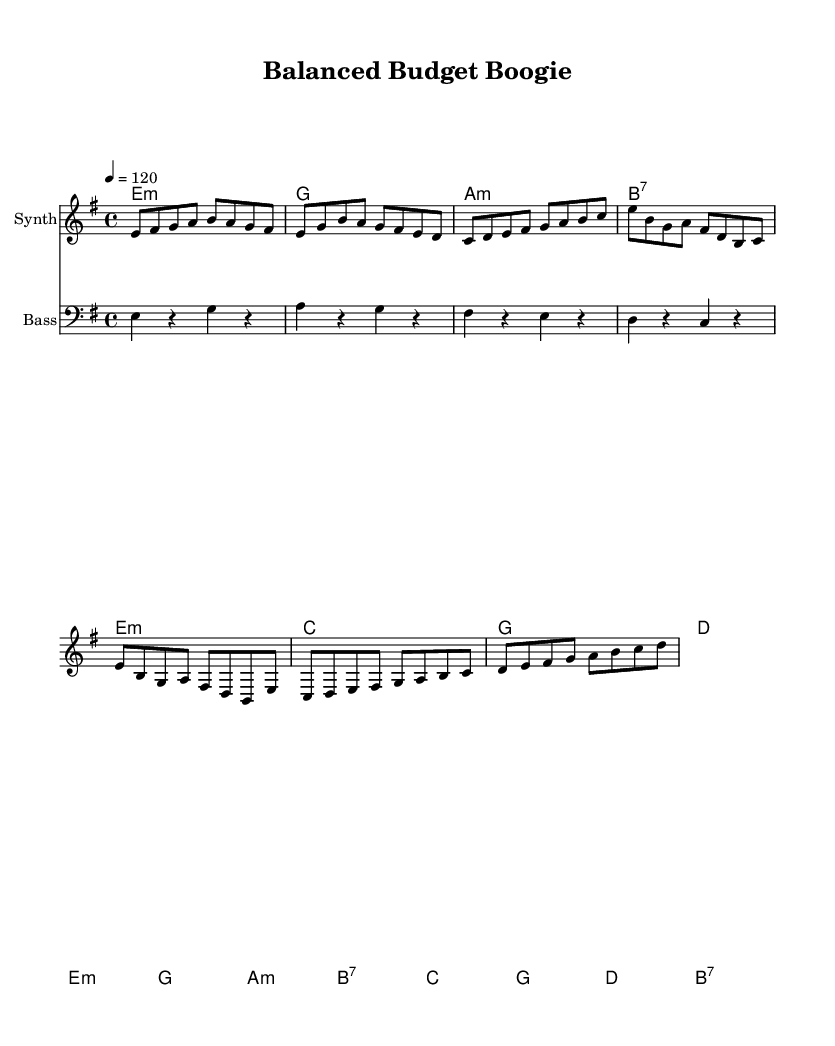What is the key signature of this music? The key signature is E minor, which has one sharp (F#). This can be identified at the beginning of the sheet music, where the key signature is indicated.
Answer: E minor What is the time signature of this music? The time signature is 4/4, which means there are four beats in each measure and the quarter note gets one beat. This is noted at the beginning of the sheet music right after the key signature.
Answer: 4/4 What is the tempo marking for this piece? The tempo marking is 120 beats per minute, indicated by the "4 = 120" at the beginning of the music. This means that the quarter note should be played at a speed of 120 beats in one minute.
Answer: 120 How many measures are in the chorus section? The chorus section contains four measures, which can be counted in the melody lines where the chorus is notated from the first note of the chorus to the last.
Answer: 4 In what style does this piece primarily combine electronic and funk influences? The piece incorporates electronic sounds and rhythmic patterns typical of funk music, using syncopation and a strong bass line to create a danceable groove found in both styles. This can be deduced from the genre classification and instrumentation typical to both genres.
Answer: Electronic-funk Which section contains the most harmonic variety? The bridge section contains more harmonic variety, as it includes more different chords compared to the verse and chorus. This can be seen in the chord changes that occur during the bridge, where more different chords are introduced.
Answer: Bridge What is the overall mood conveyed by this music? The overall mood is upbeat and lively, which is common in electronic-funk music. Elements such as the tempo, rhythm, and harmonic choices contribute to creating a playful and energetic atmosphere. This is interpreted broadly from the sound character and stylistic choices present in the piece.
Answer: Upbeat 